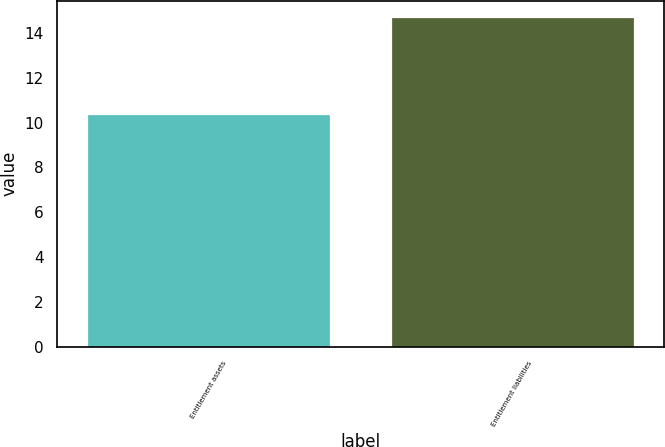Convert chart to OTSL. <chart><loc_0><loc_0><loc_500><loc_500><bar_chart><fcel>Entitlement assets<fcel>Entitlement liabilities<nl><fcel>10.4<fcel>14.7<nl></chart> 